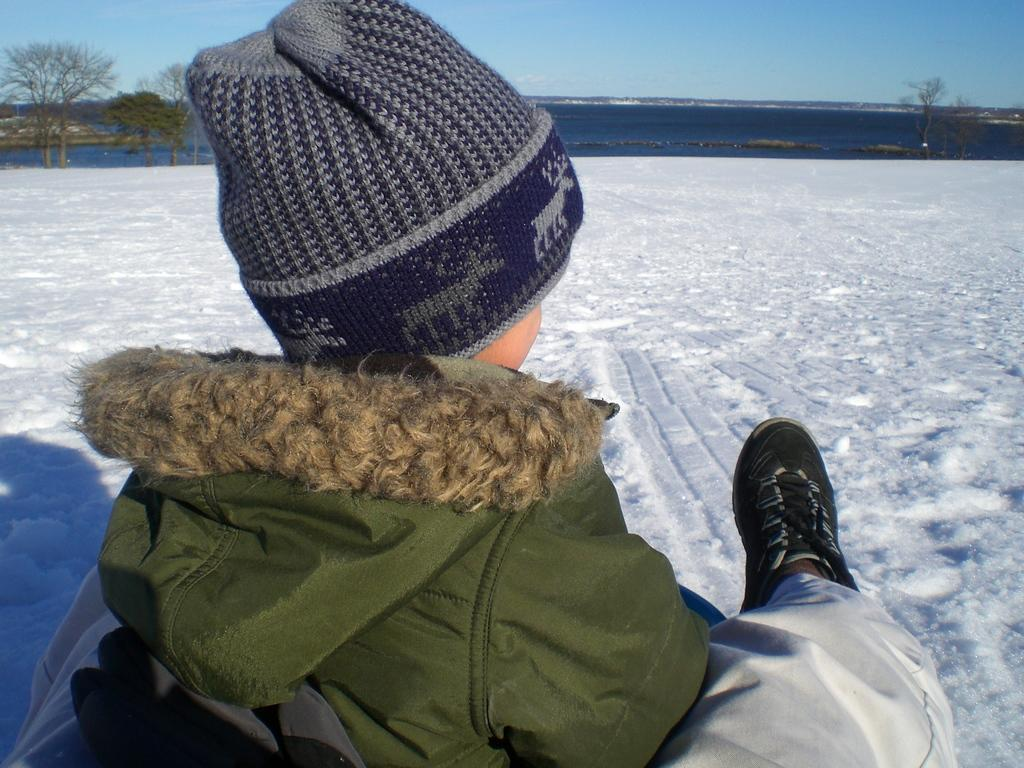What is the child doing in the image? The child is sitting in the image. What type of surface is the child sitting on? There is a snow surface in the image. What can be seen in the background of the image? The sky, water, and trees are visible in the background of the image. What type of collar is the child wearing in the image? There is no collar visible on the child in the image. Can you describe the flame that is present in the image? There is no flame present in the image. 